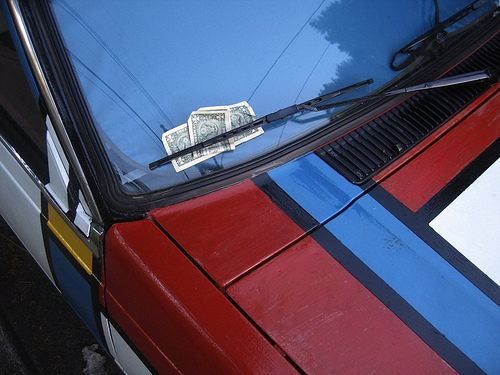<image>
Is the money next to the car? No. The money is not positioned next to the car. They are located in different areas of the scene. Is the money on the window? Yes. Looking at the image, I can see the money is positioned on top of the window, with the window providing support. Is there a money in front of the vent? No. The money is not in front of the vent. The spatial positioning shows a different relationship between these objects. 